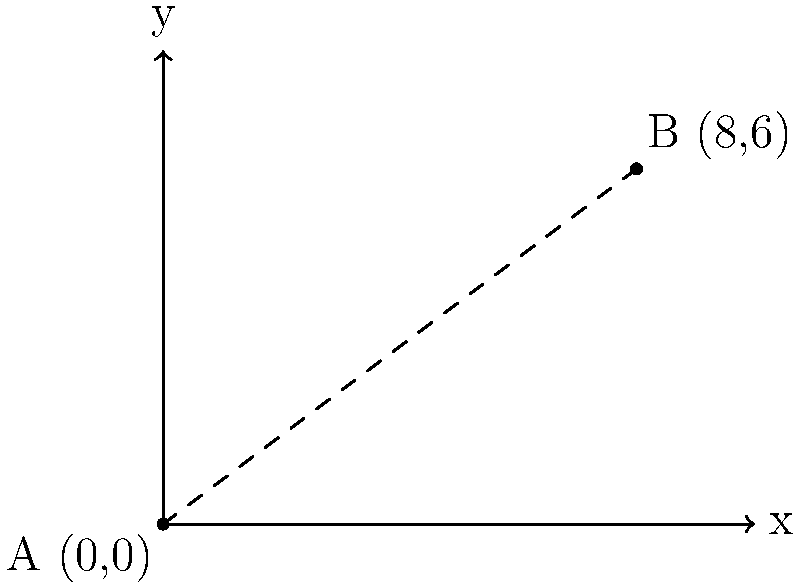In a punk-infested urban landscape, two iconic underground concert venues are located on a city map. Venue A is at the origin (0,0), while Venue B is at coordinates (8,6). As an anti-fascist organizer planning a secret show, you need to calculate the straight-line distance between these two venues to ensure safe transportation of equipment. Using the distance formula, determine the distance between Venue A and Venue B. To solve this problem, we'll use the distance formula derived from the Pythagorean theorem:

$$d = \sqrt{(x_2 - x_1)^2 + (y_2 - y_1)^2}$$

Where $(x_1, y_1)$ are the coordinates of the first point and $(x_2, y_2)$ are the coordinates of the second point.

Given:
- Venue A: $(x_1, y_1) = (0, 0)$
- Venue B: $(x_2, y_2) = (8, 6)$

Step 1: Substitute the values into the distance formula:
$$d = \sqrt{(8 - 0)^2 + (6 - 0)^2}$$

Step 2: Simplify the expressions inside the parentheses:
$$d = \sqrt{8^2 + 6^2}$$

Step 3: Calculate the squares:
$$d = \sqrt{64 + 36}$$

Step 4: Add the values under the square root:
$$d = \sqrt{100}$$

Step 5: Simplify the square root:
$$d = 10$$

Therefore, the distance between Venue A and Venue B is 10 units on the city map.
Answer: 10 units 